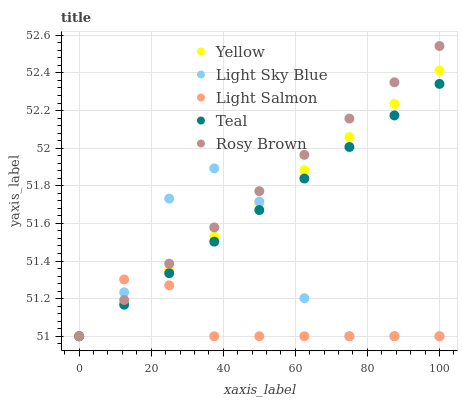Does Light Salmon have the minimum area under the curve?
Answer yes or no. Yes. Does Rosy Brown have the maximum area under the curve?
Answer yes or no. Yes. Does Light Sky Blue have the minimum area under the curve?
Answer yes or no. No. Does Light Sky Blue have the maximum area under the curve?
Answer yes or no. No. Is Teal the smoothest?
Answer yes or no. Yes. Is Light Sky Blue the roughest?
Answer yes or no. Yes. Is Rosy Brown the smoothest?
Answer yes or no. No. Is Rosy Brown the roughest?
Answer yes or no. No. Does Light Salmon have the lowest value?
Answer yes or no. Yes. Does Rosy Brown have the highest value?
Answer yes or no. Yes. Does Light Sky Blue have the highest value?
Answer yes or no. No. Does Light Sky Blue intersect Light Salmon?
Answer yes or no. Yes. Is Light Sky Blue less than Light Salmon?
Answer yes or no. No. Is Light Sky Blue greater than Light Salmon?
Answer yes or no. No. 